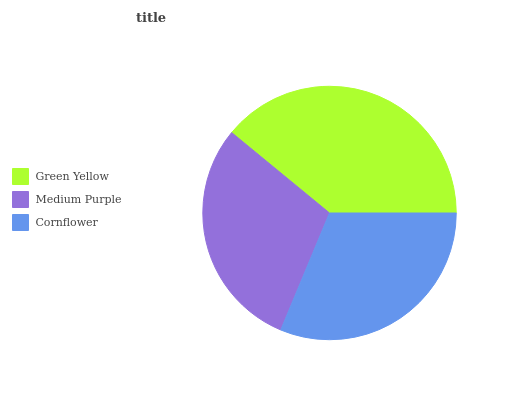Is Medium Purple the minimum?
Answer yes or no. Yes. Is Green Yellow the maximum?
Answer yes or no. Yes. Is Cornflower the minimum?
Answer yes or no. No. Is Cornflower the maximum?
Answer yes or no. No. Is Cornflower greater than Medium Purple?
Answer yes or no. Yes. Is Medium Purple less than Cornflower?
Answer yes or no. Yes. Is Medium Purple greater than Cornflower?
Answer yes or no. No. Is Cornflower less than Medium Purple?
Answer yes or no. No. Is Cornflower the high median?
Answer yes or no. Yes. Is Cornflower the low median?
Answer yes or no. Yes. Is Green Yellow the high median?
Answer yes or no. No. Is Green Yellow the low median?
Answer yes or no. No. 